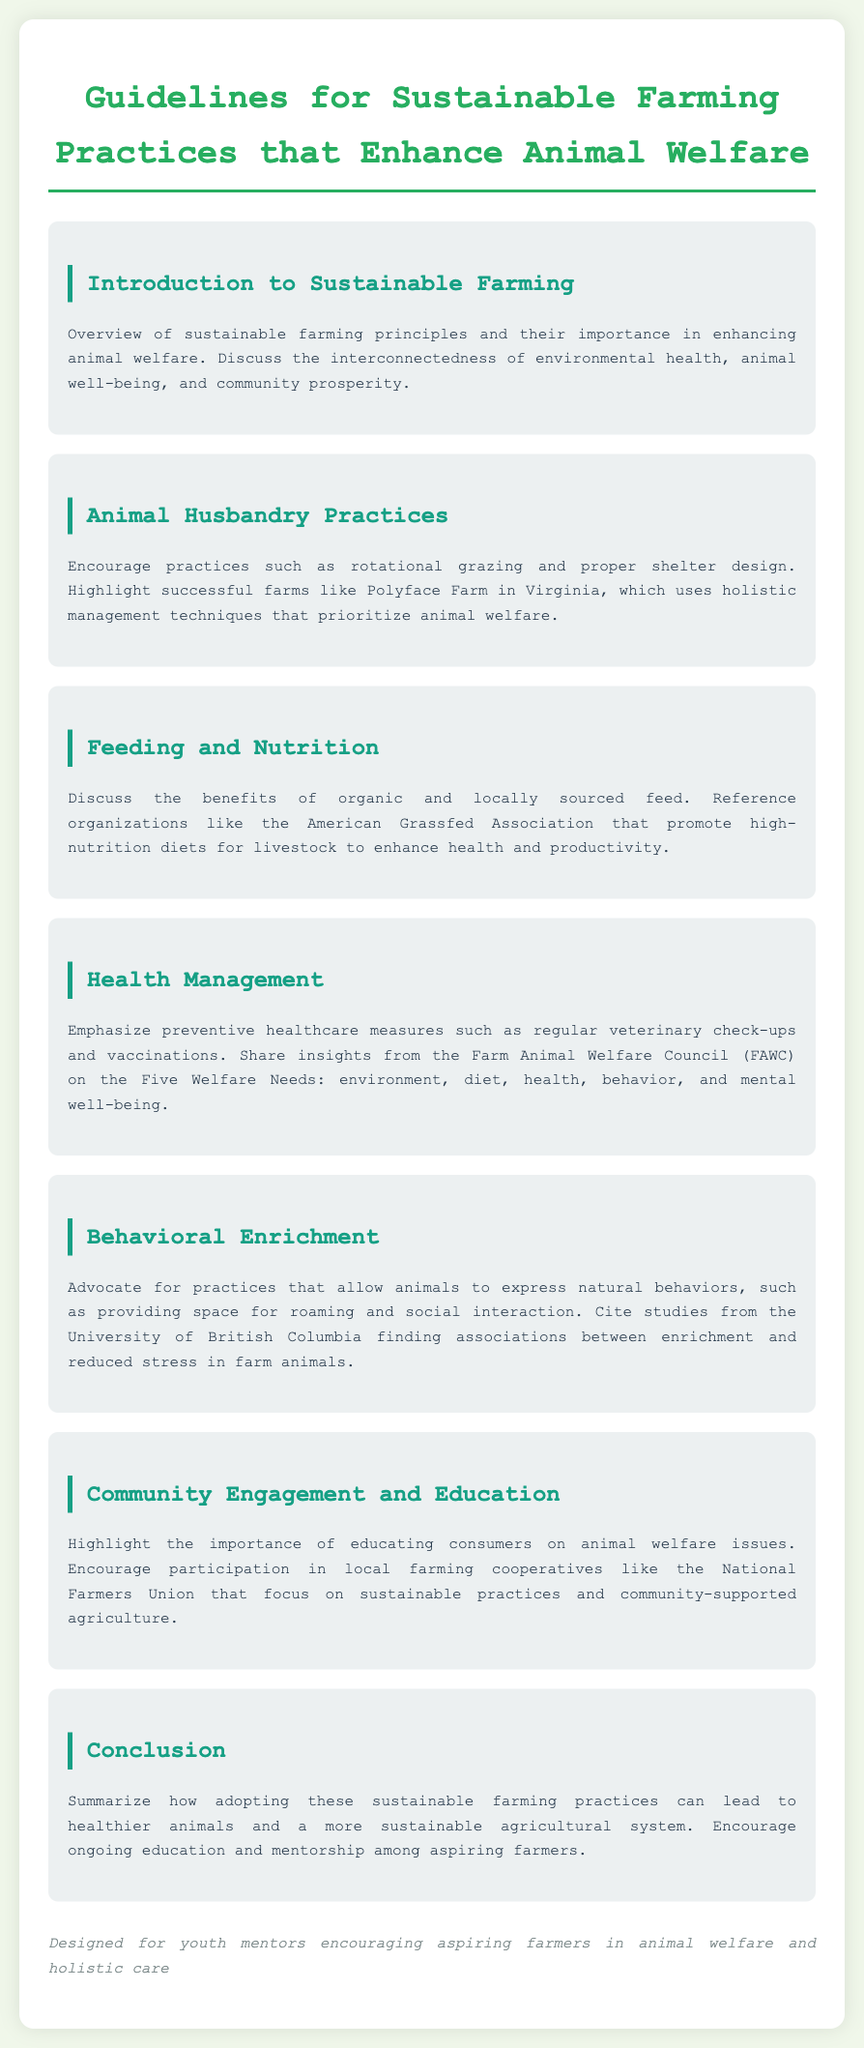What are the principles of sustainable farming? The principles include environmental health, animal well-being, and community prosperity.
Answer: Environmental health, animal well-being, community prosperity What is an example of an animal husbandry practice? Rotational grazing is highlighted as a practice that enhances animal welfare.
Answer: Rotational grazing Which organization promotes high-nutrition diets for livestock? The American Grassfed Association is mentioned in relation to feeding and nutrition.
Answer: American Grassfed Association What are the Five Welfare Needs according to the Farm Animal Welfare Council? The Five Welfare Needs are environment, diet, health, behavior, and mental well-being.
Answer: Environment, diet, health, behavior, mental well-being What is a benefit of providing behavioral enrichment to farm animals? Providing space for roaming and social interaction can reduce stress in farm animals.
Answer: Reduced stress Which university conducted studies on behavioral enrichment in farm animals? The University of British Columbia is cited for its studies related to animal enrichment.
Answer: University of British Columbia What is the main goal of educating consumers about animal welfare issues? The goal is to increase awareness and support for sustainable practices.
Answer: Increase awareness What does the conclusion emphasize regarding sustainable farming practices? The conclusion emphasizes adopting sustainable practices leads to healthier animals and a sustainable agricultural system.
Answer: Healthier animals and sustainable agricultural system 